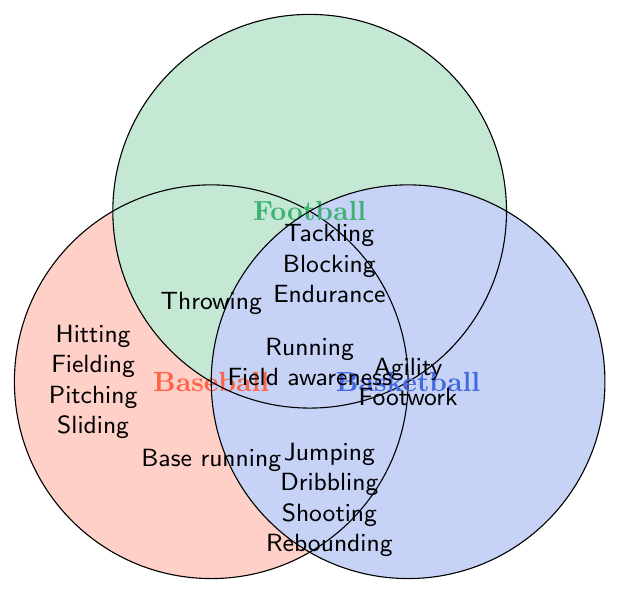What skills are unique to baseball? The baseball section contains skills that are not shared with either football or basketball. These skills are Hitting, Fielding, Pitching, and Sliding.
Answer: Hitting, Fielding, Pitching, Sliding Which skill is common to all three sports? The overlapping section of all three circles shows the skill "Throwing," which is shared by baseball, football, and basketball.
Answer: Throwing What skills are shared between baseball and football but not with basketball? The overlapping area between the baseball and football circles shows skills common to both but not shared with basketball. These are Running and Field awareness.
Answer: Running, Field awareness What skills do football and basketball share that baseball does not? The overlapping section between football and basketball circles includes skills that baseball does not share. These are Tackling, Blocking, and Endurance.
Answer: Tackling, Blocking, Endurance Which skills are unique to the sport of basketball? The segment of the basketball circle that does not overlap with either the baseball or football circles shows skills unique to basketball: Jumping, Dribbling, Shooting, and Rebounding.
Answer: Jumping, Dribbling, Shooting, Rebounding How many skills are shared between baseball and basketball but not with football? The overlapping section between baseball and basketball circles is empty, indicating that there are no shared skills between these two sports that are not also shared with football.
Answer: 0 What skills do all three sports need that also involve physical movement? The skill common to all three sports involving physical movement is "Throwing," as it appears at the intersection of all three circles.
Answer: Throwing Which skill is shared between football and basketball, and also enhances endurance? The skill "Endurance" is located in the overlapping section between football and basketball, and it specifically enhances endurance.
Answer: Endurance What skills related to strategic awareness are shared by football and baseball? The skill "Field awareness" appears in the overlapping section between baseball and football, indicating it is shared by both and is related to strategic awareness.
Answer: Field awareness 